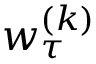<formula> <loc_0><loc_0><loc_500><loc_500>w _ { \tau } ^ { ( k ) }</formula> 